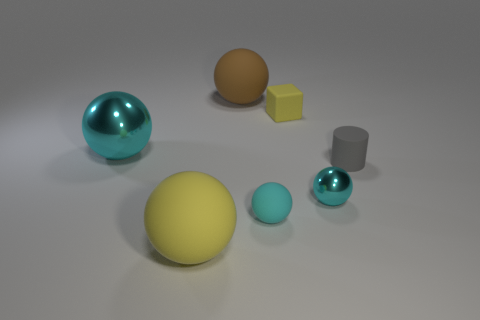Subtract all cyan balls. How many were subtracted if there are1cyan balls left? 2 Subtract all red blocks. How many cyan balls are left? 3 Subtract all yellow spheres. How many spheres are left? 4 Subtract all large shiny balls. How many balls are left? 4 Subtract all blue spheres. Subtract all cyan cylinders. How many spheres are left? 5 Add 3 small cyan metal cylinders. How many objects exist? 10 Subtract all spheres. How many objects are left? 2 Add 3 small objects. How many small objects are left? 7 Add 1 yellow rubber spheres. How many yellow rubber spheres exist? 2 Subtract 0 cyan blocks. How many objects are left? 7 